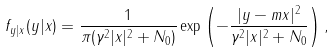<formula> <loc_0><loc_0><loc_500><loc_500>f _ { y | x } ( y | x ) = \frac { 1 } { \pi ( \gamma ^ { 2 } | x | ^ { 2 } + N _ { 0 } ) } \exp \left ( - \frac { | y - m x | ^ { 2 } } { \gamma ^ { 2 } | x | ^ { 2 } + N _ { 0 } } \right ) ,</formula> 